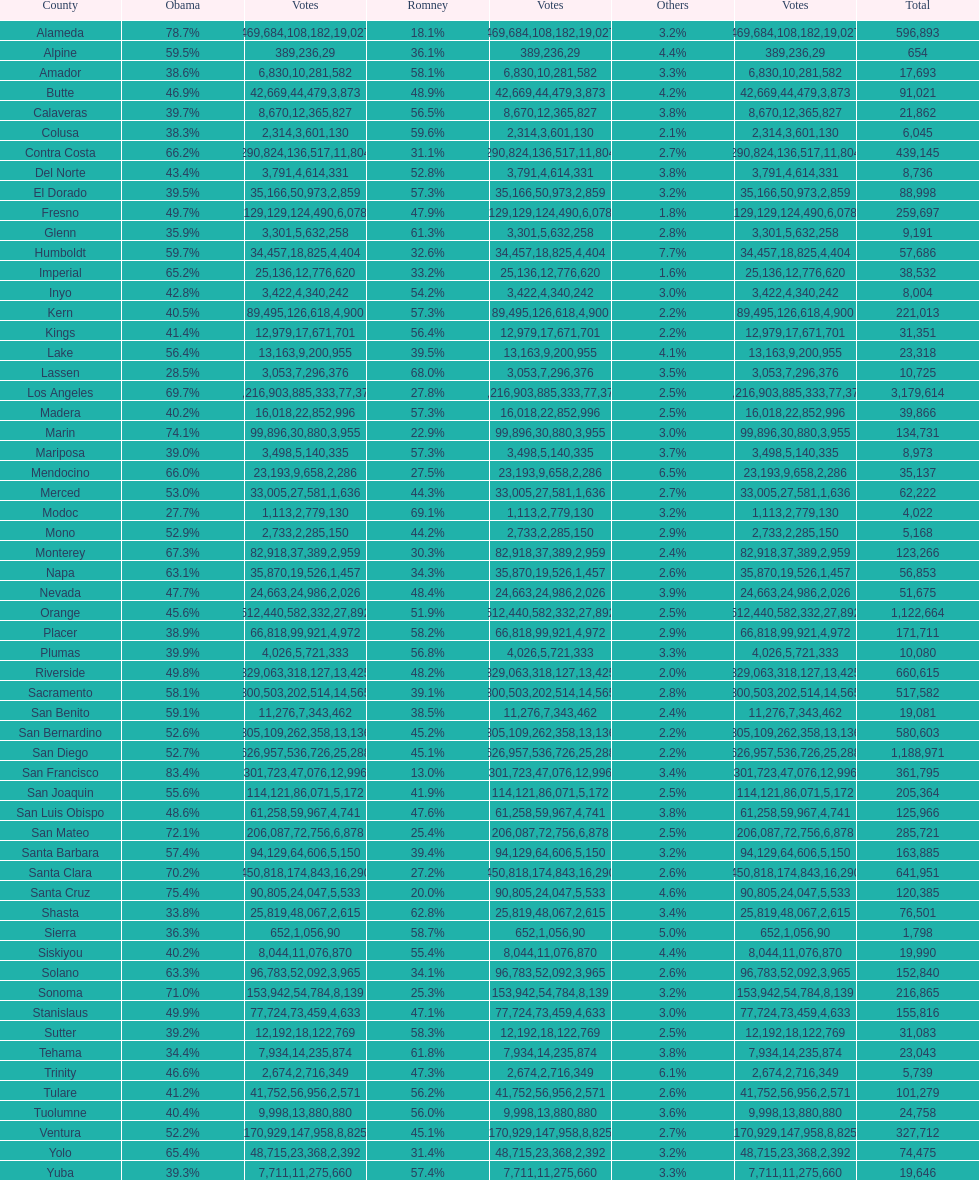Was romney's vote count in alameda county higher or lower than obama's? Less. 